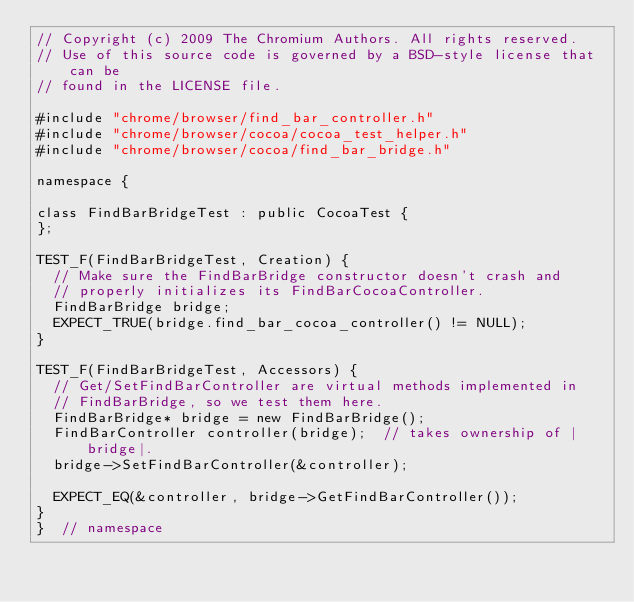Convert code to text. <code><loc_0><loc_0><loc_500><loc_500><_ObjectiveC_>// Copyright (c) 2009 The Chromium Authors. All rights reserved.
// Use of this source code is governed by a BSD-style license that can be
// found in the LICENSE file.

#include "chrome/browser/find_bar_controller.h"
#include "chrome/browser/cocoa/cocoa_test_helper.h"
#include "chrome/browser/cocoa/find_bar_bridge.h"

namespace {

class FindBarBridgeTest : public CocoaTest {
};

TEST_F(FindBarBridgeTest, Creation) {
  // Make sure the FindBarBridge constructor doesn't crash and
  // properly initializes its FindBarCocoaController.
  FindBarBridge bridge;
  EXPECT_TRUE(bridge.find_bar_cocoa_controller() != NULL);
}

TEST_F(FindBarBridgeTest, Accessors) {
  // Get/SetFindBarController are virtual methods implemented in
  // FindBarBridge, so we test them here.
  FindBarBridge* bridge = new FindBarBridge();
  FindBarController controller(bridge);  // takes ownership of |bridge|.
  bridge->SetFindBarController(&controller);

  EXPECT_EQ(&controller, bridge->GetFindBarController());
}
}  // namespace
</code> 